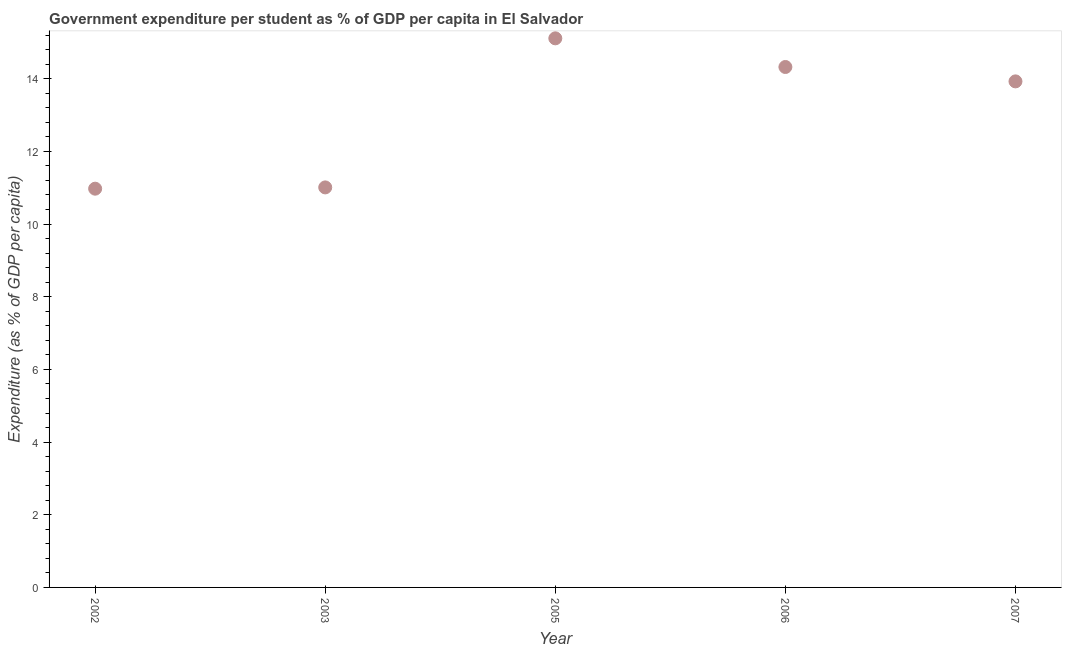What is the government expenditure per student in 2006?
Make the answer very short. 14.32. Across all years, what is the maximum government expenditure per student?
Provide a short and direct response. 15.11. Across all years, what is the minimum government expenditure per student?
Provide a succinct answer. 10.97. In which year was the government expenditure per student maximum?
Your response must be concise. 2005. In which year was the government expenditure per student minimum?
Your answer should be compact. 2002. What is the sum of the government expenditure per student?
Offer a very short reply. 65.34. What is the difference between the government expenditure per student in 2003 and 2007?
Give a very brief answer. -2.92. What is the average government expenditure per student per year?
Your answer should be very brief. 13.07. What is the median government expenditure per student?
Offer a terse response. 13.93. In how many years, is the government expenditure per student greater than 10 %?
Keep it short and to the point. 5. Do a majority of the years between 2002 and 2007 (inclusive) have government expenditure per student greater than 5.6 %?
Your answer should be very brief. Yes. What is the ratio of the government expenditure per student in 2002 to that in 2003?
Give a very brief answer. 1. Is the government expenditure per student in 2003 less than that in 2006?
Offer a terse response. Yes. Is the difference between the government expenditure per student in 2005 and 2007 greater than the difference between any two years?
Your answer should be very brief. No. What is the difference between the highest and the second highest government expenditure per student?
Give a very brief answer. 0.79. What is the difference between the highest and the lowest government expenditure per student?
Ensure brevity in your answer.  4.14. Does the government expenditure per student monotonically increase over the years?
Offer a terse response. No. What is the difference between two consecutive major ticks on the Y-axis?
Give a very brief answer. 2. Are the values on the major ticks of Y-axis written in scientific E-notation?
Your response must be concise. No. Does the graph contain any zero values?
Offer a very short reply. No. What is the title of the graph?
Your response must be concise. Government expenditure per student as % of GDP per capita in El Salvador. What is the label or title of the Y-axis?
Your answer should be compact. Expenditure (as % of GDP per capita). What is the Expenditure (as % of GDP per capita) in 2002?
Your response must be concise. 10.97. What is the Expenditure (as % of GDP per capita) in 2003?
Offer a very short reply. 11.01. What is the Expenditure (as % of GDP per capita) in 2005?
Your response must be concise. 15.11. What is the Expenditure (as % of GDP per capita) in 2006?
Your answer should be very brief. 14.32. What is the Expenditure (as % of GDP per capita) in 2007?
Keep it short and to the point. 13.93. What is the difference between the Expenditure (as % of GDP per capita) in 2002 and 2003?
Make the answer very short. -0.04. What is the difference between the Expenditure (as % of GDP per capita) in 2002 and 2005?
Your answer should be compact. -4.14. What is the difference between the Expenditure (as % of GDP per capita) in 2002 and 2006?
Provide a short and direct response. -3.35. What is the difference between the Expenditure (as % of GDP per capita) in 2002 and 2007?
Your answer should be very brief. -2.95. What is the difference between the Expenditure (as % of GDP per capita) in 2003 and 2005?
Give a very brief answer. -4.1. What is the difference between the Expenditure (as % of GDP per capita) in 2003 and 2006?
Offer a very short reply. -3.31. What is the difference between the Expenditure (as % of GDP per capita) in 2003 and 2007?
Provide a short and direct response. -2.92. What is the difference between the Expenditure (as % of GDP per capita) in 2005 and 2006?
Provide a short and direct response. 0.79. What is the difference between the Expenditure (as % of GDP per capita) in 2005 and 2007?
Offer a terse response. 1.18. What is the difference between the Expenditure (as % of GDP per capita) in 2006 and 2007?
Your answer should be compact. 0.4. What is the ratio of the Expenditure (as % of GDP per capita) in 2002 to that in 2003?
Provide a short and direct response. 1. What is the ratio of the Expenditure (as % of GDP per capita) in 2002 to that in 2005?
Ensure brevity in your answer.  0.73. What is the ratio of the Expenditure (as % of GDP per capita) in 2002 to that in 2006?
Your response must be concise. 0.77. What is the ratio of the Expenditure (as % of GDP per capita) in 2002 to that in 2007?
Your response must be concise. 0.79. What is the ratio of the Expenditure (as % of GDP per capita) in 2003 to that in 2005?
Your answer should be very brief. 0.73. What is the ratio of the Expenditure (as % of GDP per capita) in 2003 to that in 2006?
Provide a short and direct response. 0.77. What is the ratio of the Expenditure (as % of GDP per capita) in 2003 to that in 2007?
Provide a short and direct response. 0.79. What is the ratio of the Expenditure (as % of GDP per capita) in 2005 to that in 2006?
Your answer should be compact. 1.05. What is the ratio of the Expenditure (as % of GDP per capita) in 2005 to that in 2007?
Provide a succinct answer. 1.08. What is the ratio of the Expenditure (as % of GDP per capita) in 2006 to that in 2007?
Offer a terse response. 1.03. 